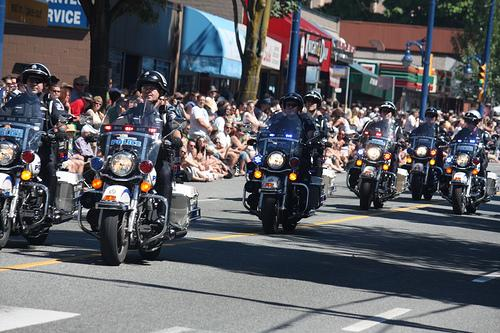Where do you go in this street if you want to buy candy? Please explain your reasoning. convenience store. The convenience store has candy. 